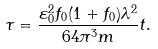<formula> <loc_0><loc_0><loc_500><loc_500>\tau = \frac { \varepsilon _ { 0 } ^ { 2 } f _ { 0 } ( 1 + f _ { 0 } ) \lambda ^ { 2 } } { 6 4 \pi ^ { 3 } m } t .</formula> 